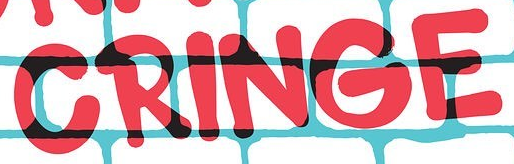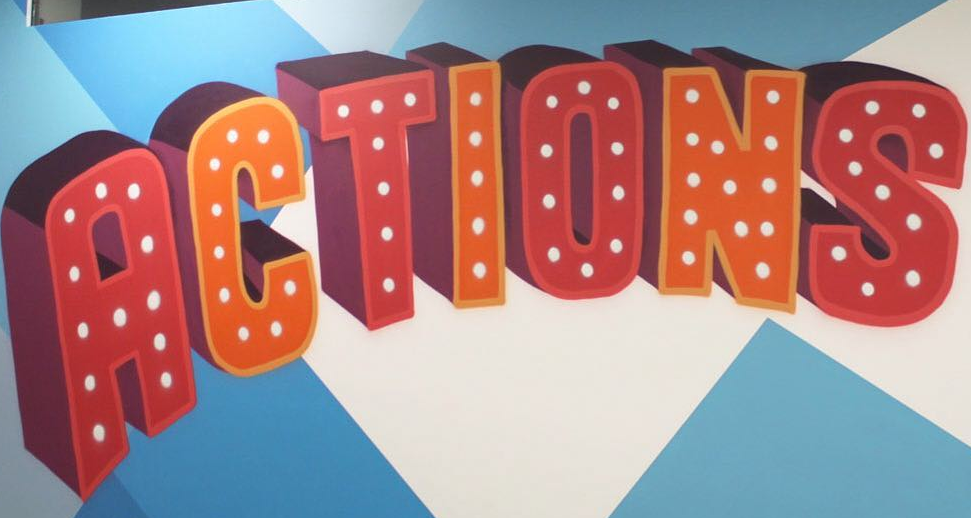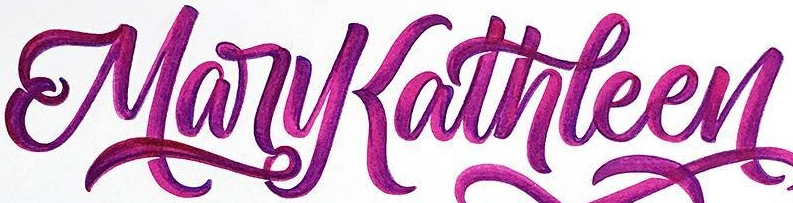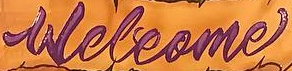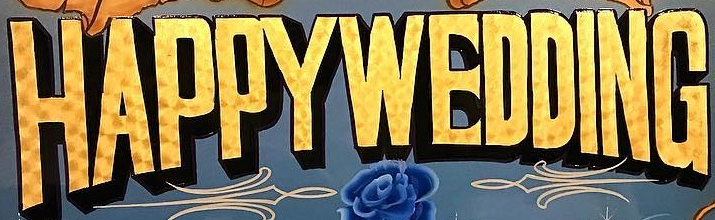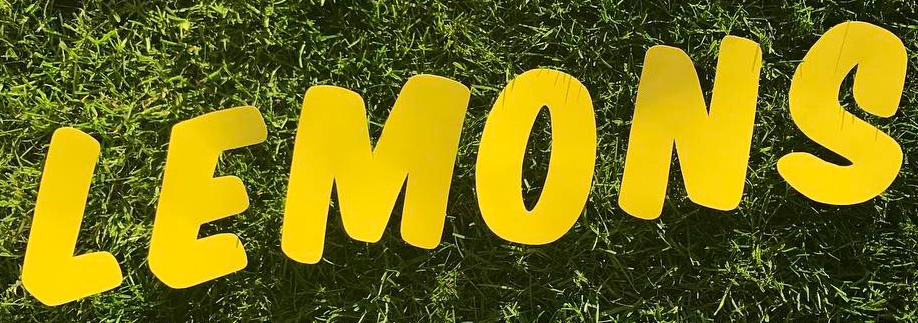What text is displayed in these images sequentially, separated by a semicolon? CRINGE; ACTIONS; MaryKathleen; Welcome; HAPPYWEDDING; LEMONS 